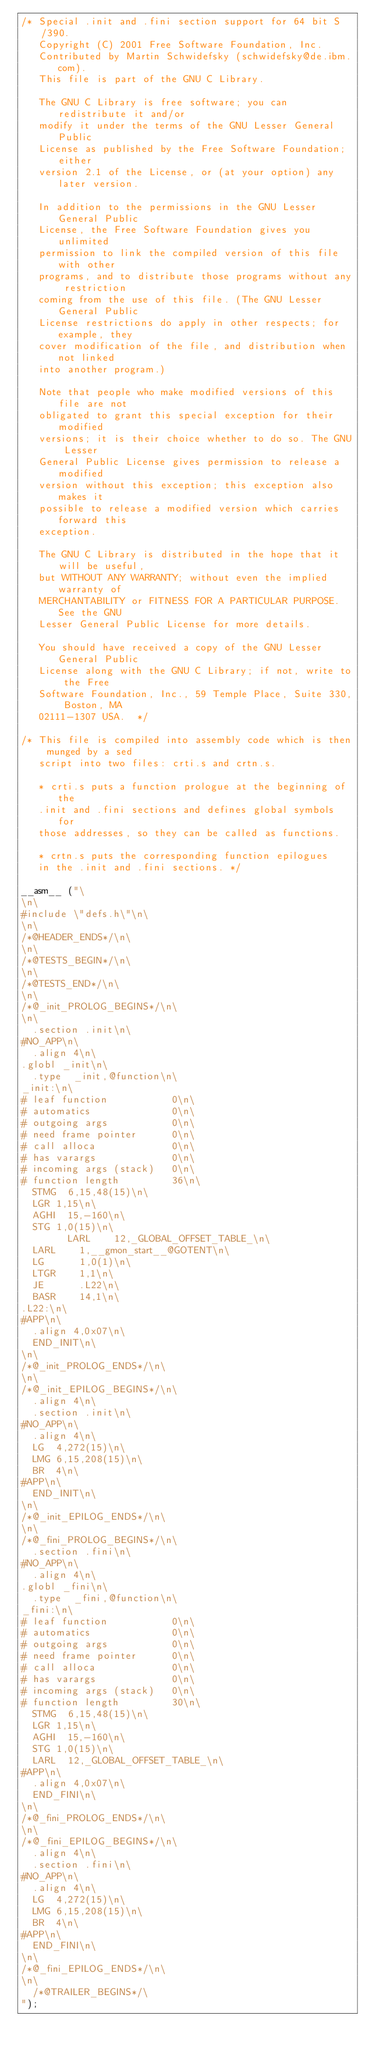<code> <loc_0><loc_0><loc_500><loc_500><_C_>/* Special .init and .fini section support for 64 bit S/390.
   Copyright (C) 2001 Free Software Foundation, Inc.
   Contributed by Martin Schwidefsky (schwidefsky@de.ibm.com).
   This file is part of the GNU C Library.

   The GNU C Library is free software; you can redistribute it and/or
   modify it under the terms of the GNU Lesser General Public
   License as published by the Free Software Foundation; either
   version 2.1 of the License, or (at your option) any later version.

   In addition to the permissions in the GNU Lesser General Public
   License, the Free Software Foundation gives you unlimited
   permission to link the compiled version of this file with other
   programs, and to distribute those programs without any restriction
   coming from the use of this file. (The GNU Lesser General Public
   License restrictions do apply in other respects; for example, they
   cover modification of the file, and distribution when not linked
   into another program.)

   Note that people who make modified versions of this file are not
   obligated to grant this special exception for their modified
   versions; it is their choice whether to do so. The GNU Lesser
   General Public License gives permission to release a modified
   version without this exception; this exception also makes it
   possible to release a modified version which carries forward this
   exception.

   The GNU C Library is distributed in the hope that it will be useful,
   but WITHOUT ANY WARRANTY; without even the implied warranty of
   MERCHANTABILITY or FITNESS FOR A PARTICULAR PURPOSE.  See the GNU
   Lesser General Public License for more details.

   You should have received a copy of the GNU Lesser General Public
   License along with the GNU C Library; if not, write to the Free
   Software Foundation, Inc., 59 Temple Place, Suite 330, Boston, MA
   02111-1307 USA.  */

/* This file is compiled into assembly code which is then munged by a sed
   script into two files: crti.s and crtn.s.

   * crti.s puts a function prologue at the beginning of the
   .init and .fini sections and defines global symbols for
   those addresses, so they can be called as functions.

   * crtn.s puts the corresponding function epilogues
   in the .init and .fini sections. */

__asm__ ("\
\n\
#include \"defs.h\"\n\
\n\
/*@HEADER_ENDS*/\n\
\n\
/*@TESTS_BEGIN*/\n\
\n\
/*@TESTS_END*/\n\
\n\
/*@_init_PROLOG_BEGINS*/\n\
\n\
	.section .init\n\
#NO_APP\n\
	.align 4\n\
.globl _init\n\
	.type	 _init,@function\n\
_init:\n\
#	leaf function           0\n\
#	automatics              0\n\
#	outgoing args           0\n\
#	need frame pointer      0\n\
#	call alloca             0\n\
#	has varargs             0\n\
#	incoming args (stack)   0\n\
#	function length         36\n\
	STMG	6,15,48(15)\n\
	LGR	1,15\n\
	AGHI	15,-160\n\
	STG	1,0(15)\n\
        LARL    12,_GLOBAL_OFFSET_TABLE_\n\
	LARL    1,__gmon_start__@GOTENT\n\
	LG      1,0(1)\n\
	LTGR    1,1\n\
	JE      .L22\n\
	BASR    14,1\n\
.L22:\n\
#APP\n\
	.align 4,0x07\n\
	END_INIT\n\
\n\
/*@_init_PROLOG_ENDS*/\n\
\n\
/*@_init_EPILOG_BEGINS*/\n\
	.align 4\n\
	.section .init\n\
#NO_APP\n\
	.align 4\n\
	LG	4,272(15)\n\
	LMG	6,15,208(15)\n\
	BR	4\n\
#APP\n\
	END_INIT\n\
\n\
/*@_init_EPILOG_ENDS*/\n\
\n\
/*@_fini_PROLOG_BEGINS*/\n\
	.section .fini\n\
#NO_APP\n\
	.align 4\n\
.globl _fini\n\
	.type	 _fini,@function\n\
_fini:\n\
#	leaf function           0\n\
#	automatics              0\n\
#	outgoing args           0\n\
#	need frame pointer      0\n\
#	call alloca             0\n\
#	has varargs             0\n\
#	incoming args (stack)   0\n\
#	function length         30\n\
	STMG	6,15,48(15)\n\
	LGR	1,15\n\
	AGHI	15,-160\n\
	STG	1,0(15)\n\
	LARL	12,_GLOBAL_OFFSET_TABLE_\n\
#APP\n\
	.align 4,0x07\n\
	END_FINI\n\
\n\
/*@_fini_PROLOG_ENDS*/\n\
\n\
/*@_fini_EPILOG_BEGINS*/\n\
	.align 4\n\
	.section .fini\n\
#NO_APP\n\
	.align 4\n\
	LG	4,272(15)\n\
	LMG	6,15,208(15)\n\
	BR	4\n\
#APP\n\
	END_FINI\n\
\n\
/*@_fini_EPILOG_ENDS*/\n\
\n\
	/*@TRAILER_BEGINS*/\
");
</code> 